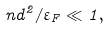<formula> <loc_0><loc_0><loc_500><loc_500>n d ^ { 2 } / \varepsilon _ { F } \ll 1 ,</formula> 